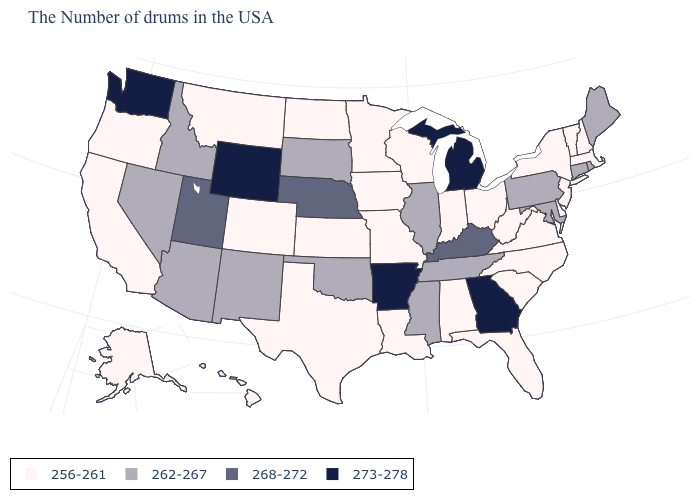Does Tennessee have the lowest value in the USA?
Answer briefly. No. What is the value of Pennsylvania?
Be succinct. 262-267. How many symbols are there in the legend?
Give a very brief answer. 4. What is the value of Montana?
Write a very short answer. 256-261. Does South Dakota have the lowest value in the USA?
Quick response, please. No. What is the highest value in the USA?
Keep it brief. 273-278. Which states have the lowest value in the USA?
Write a very short answer. Massachusetts, New Hampshire, Vermont, New York, New Jersey, Delaware, Virginia, North Carolina, South Carolina, West Virginia, Ohio, Florida, Indiana, Alabama, Wisconsin, Louisiana, Missouri, Minnesota, Iowa, Kansas, Texas, North Dakota, Colorado, Montana, California, Oregon, Alaska, Hawaii. Which states have the highest value in the USA?
Quick response, please. Georgia, Michigan, Arkansas, Wyoming, Washington. Which states hav the highest value in the South?
Be succinct. Georgia, Arkansas. What is the value of Missouri?
Give a very brief answer. 256-261. What is the value of Tennessee?
Concise answer only. 262-267. Name the states that have a value in the range 273-278?
Quick response, please. Georgia, Michigan, Arkansas, Wyoming, Washington. What is the highest value in the USA?
Concise answer only. 273-278. Name the states that have a value in the range 273-278?
Keep it brief. Georgia, Michigan, Arkansas, Wyoming, Washington. How many symbols are there in the legend?
Write a very short answer. 4. 